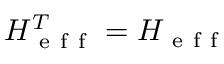<formula> <loc_0><loc_0><loc_500><loc_500>H _ { e f f } ^ { T } = H _ { e f f }</formula> 